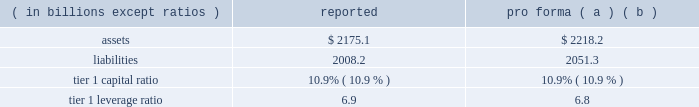Notes to consolidated financial statements 192 jpmorgan chase & co .
/ 2008 annual report consolidation analysis the multi-seller conduits administered by the firm were not consoli- dated at december 31 , 2008 and 2007 , because each conduit had issued expected loss notes ( 201celns 201d ) , the holders of which are com- mitted to absorbing the majority of the expected loss of each respective conduit .
Implied support the firm did not have and continues not to have any intent to pro- tect any eln holders from potential losses on any of the conduits 2019 holdings and has no plans to remove any assets from any conduit unless required to do so in its role as administrator .
Should such a transfer occur , the firm would allocate losses on such assets between itself and the eln holders in accordance with the terms of the applicable eln .
Expected loss modeling in determining the primary beneficiary of the conduits the firm uses a monte carlo 2013based model to estimate the expected losses of each of the conduits and considers the relative rights and obliga- tions of each of the variable interest holders .
The firm 2019s expected loss modeling treats all variable interests , other than the elns , as its own to determine consolidation .
The variability to be considered in the modeling of expected losses is based on the design of the enti- ty .
The firm 2019s traditional multi-seller conduits are designed to pass credit risk , not liquidity risk , to its variable interest holders , as the assets are intended to be held in the conduit for the longer term .
Under fin 46 ( r ) , the firm is required to run the monte carlo-based expected loss model each time a reconsideration event occurs .
In applying this guidance to the conduits , the following events , are considered to be reconsideration events , as they could affect the determination of the primary beneficiary of the conduits : 2022 new deals , including the issuance of new or additional variable interests ( credit support , liquidity facilities , etc ) ; 2022 changes in usage , including the change in the level of outstand- ing variable interests ( credit support , liquidity facilities , etc ) ; 2022 modifications of asset purchase agreements ; and 2022 sales of interests held by the primary beneficiary .
From an operational perspective , the firm does not run its monte carlo-based expected loss model every time there is a reconsideration event due to the frequency of their occurrence .
Instead , the firm runs its expected loss model each quarter and includes a growth assump- tion for each conduit to ensure that a sufficient amount of elns exists for each conduit at any point during the quarter .
As part of its normal quarterly modeling , the firm updates , when applicable , the inputs and assumptions used in the expected loss model .
Specifically , risk ratings and loss given default assumptions are continually updated .
The total amount of expected loss notes out- standing at december 31 , 2008 and 2007 , were $ 136 million and $ 130 million , respectively .
Management has concluded that the model assumptions used were reflective of market participants 2019 assumptions and appropriately considered the probability of changes to risk ratings and loss given defaults .
Qualitative considerations the multi-seller conduits are primarily designed to provide an effi- cient means for clients to access the commercial paper market .
The firm believes the conduits effectively disperse risk among all parties and that the preponderance of the economic risk in the firm 2019s multi- seller conduits is not held by jpmorgan chase .
Consolidated sensitivity analysis on capital the table below shows the impact on the firm 2019s reported assets , lia- bilities , tier 1 capital ratio and tier 1 leverage ratio if the firm were required to consolidate all of the multi-seller conduits that it admin- isters at their current carrying value .
December 31 , 2008 ( in billions , except ratios ) reported pro forma ( a ) ( b ) .
( a ) the table shows the impact of consolidating the assets and liabilities of the multi- seller conduits at their current carrying value ; as such , there would be no income statement or capital impact at the date of consolidation .
If the firm were required to consolidate the assets and liabilities of the conduits at fair value , the tier 1 capital ratio would be approximately 10.8% ( 10.8 % ) .
The fair value of the assets is primarily based upon pricing for comparable transactions .
The fair value of these assets could change significantly because the pricing of conduit transactions is renegotiated with the client , generally , on an annual basis and due to changes in current market conditions .
( b ) consolidation is assumed to occur on the first day of the quarter , at the quarter-end levels , in order to provide a meaningful adjustment to average assets in the denomi- nator of the leverage ratio .
The firm could fund purchases of assets from vies should it become necessary .
2007 activity in july 2007 , a reverse repurchase agreement collateralized by prime residential mortgages held by a firm-administered multi-seller conduit was put to jpmorgan chase under its deal-specific liquidity facility .
The asset was transferred to and recorded by jpmorgan chase at its par value based on the fair value of the collateral that supported the reverse repurchase agreement .
During the fourth quarter of 2007 , additional information regarding the value of the collateral , including performance statistics , resulted in the determi- nation by the firm that the fair value of the collateral was impaired .
Impairment losses were allocated to the eln holder ( the party that absorbs the majority of the expected loss from the conduit ) in accor- dance with the contractual provisions of the eln note .
On october 29 , 2007 , certain structured cdo assets originated in the second quarter of 2007 and backed by subprime mortgages were transferred to the firm from two firm-administered multi-seller conduits .
It became clear in october that commercial paper investors and rating agencies were becoming increasingly concerned about cdo assets backed by subprime mortgage exposures .
Because of these concerns , and to ensure the continuing viability of the two conduits as financing vehicles for clients and as investment alternatives for commercial paper investors , the firm , in its role as administrator , transferred the cdo assets out of the multi-seller con- duits .
The structured cdo assets were transferred to the firm at .
In 2008 , what was shareholders equity ( in billions ) , as reported?\\n? 
Rationale: assets - liabilities = se
Computations: (2175.1 - 2008.2)
Answer: 166.9. 